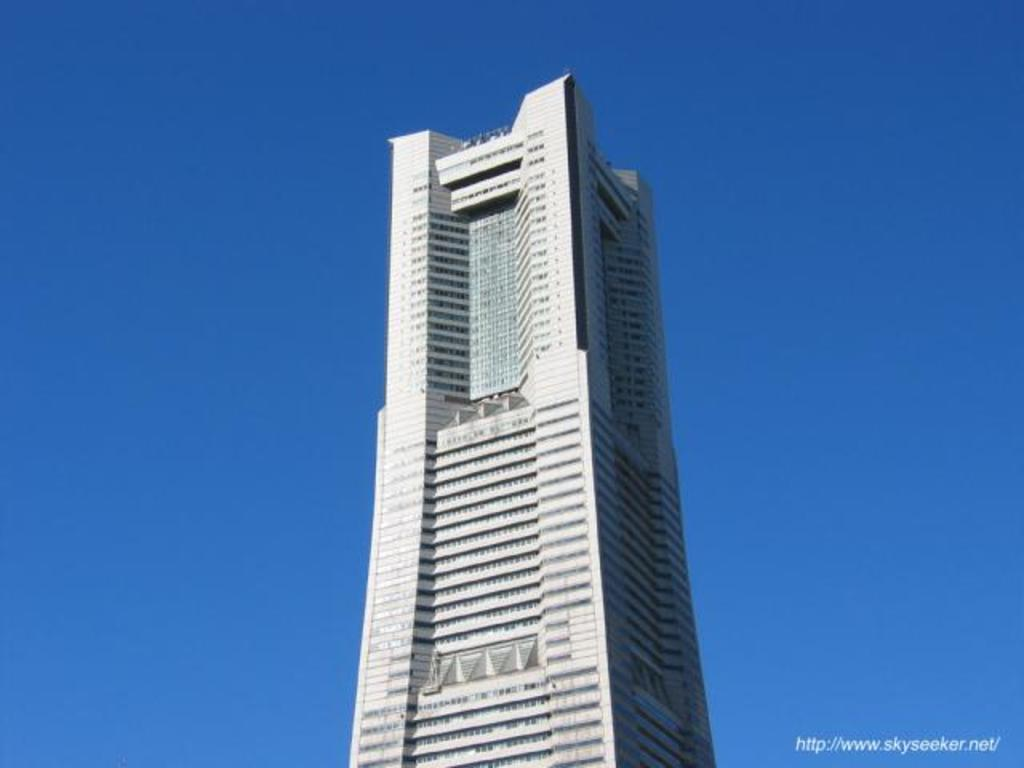What type of structure is visible in the image? There is a building in the image. What color is the sky in the image? The sky is blue in the image. What type of pancake is being served in the image? There is no pancake present in the image; it only features a building and a blue sky. 